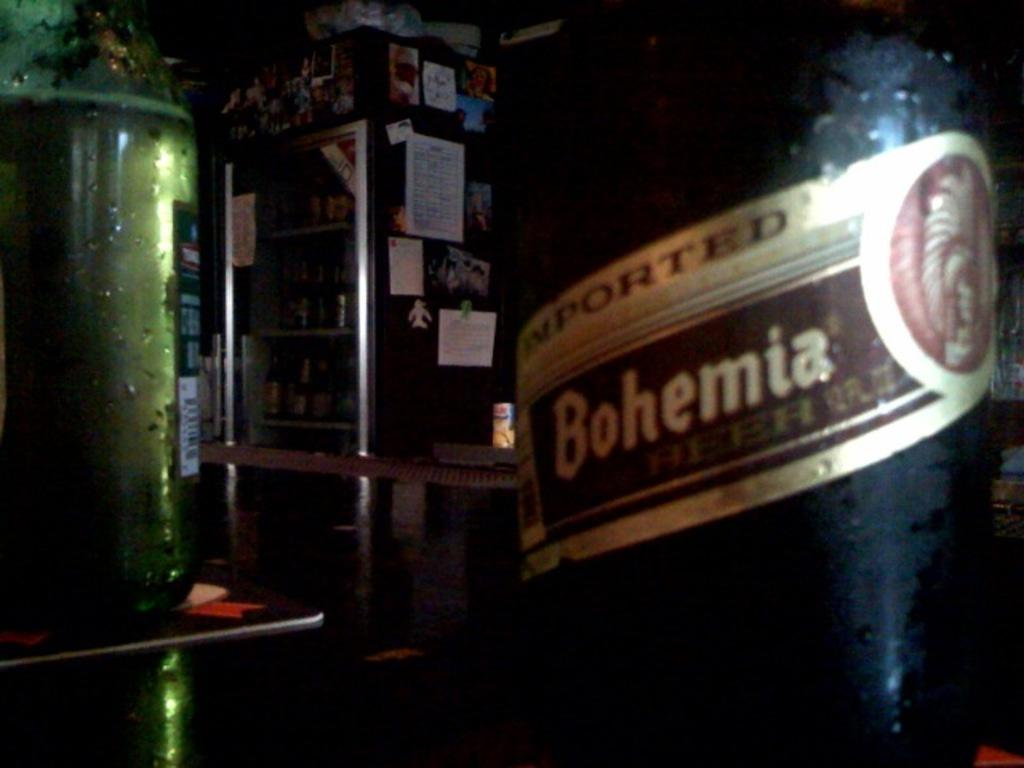<image>
Present a compact description of the photo's key features. Dark Imported Bohemia beer bottle inside of a bar. 